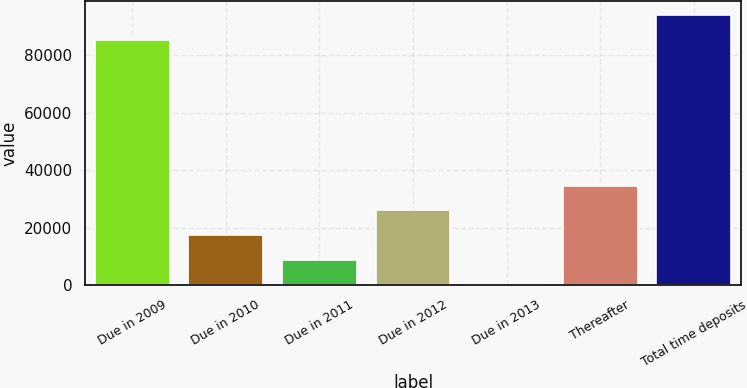<chart> <loc_0><loc_0><loc_500><loc_500><bar_chart><fcel>Due in 2009<fcel>Due in 2010<fcel>Due in 2011<fcel>Due in 2012<fcel>Due in 2013<fcel>Thereafter<fcel>Total time deposits<nl><fcel>85416<fcel>17330.8<fcel>8696.4<fcel>25965.2<fcel>62<fcel>34599.6<fcel>94050.4<nl></chart> 